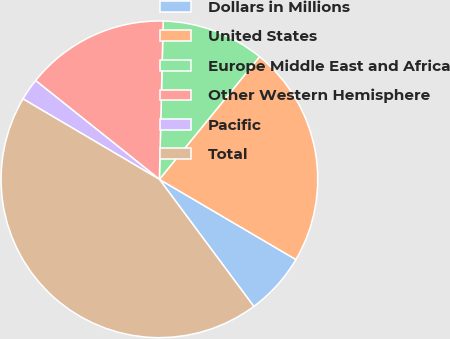Convert chart. <chart><loc_0><loc_0><loc_500><loc_500><pie_chart><fcel>Dollars in Millions<fcel>United States<fcel>Europe Middle East and Africa<fcel>Other Western Hemisphere<fcel>Pacific<fcel>Total<nl><fcel>6.38%<fcel>22.56%<fcel>10.52%<fcel>14.66%<fcel>2.24%<fcel>43.65%<nl></chart> 